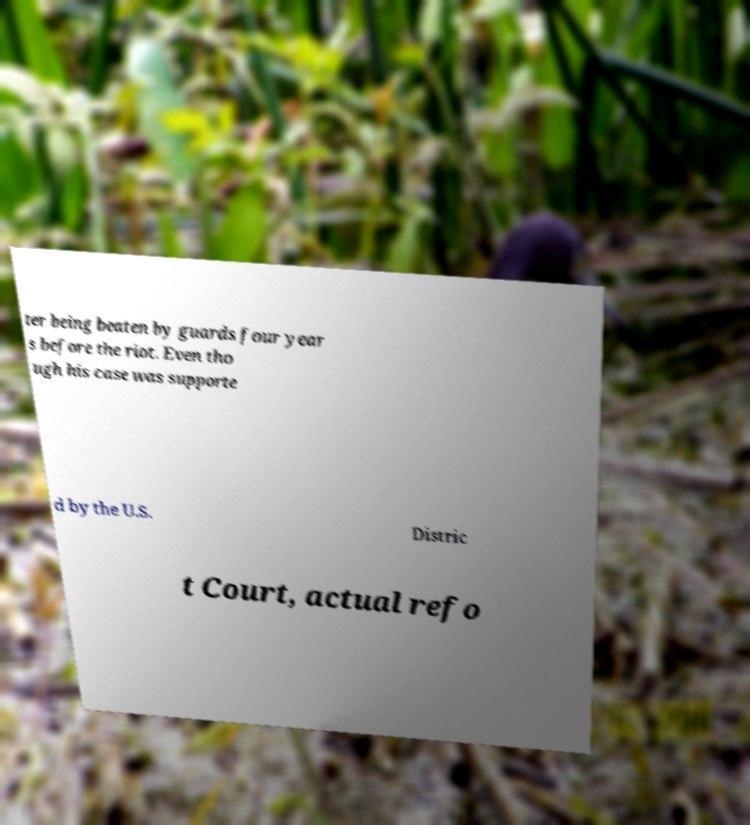Could you assist in decoding the text presented in this image and type it out clearly? ter being beaten by guards four year s before the riot. Even tho ugh his case was supporte d by the U.S. Distric t Court, actual refo 